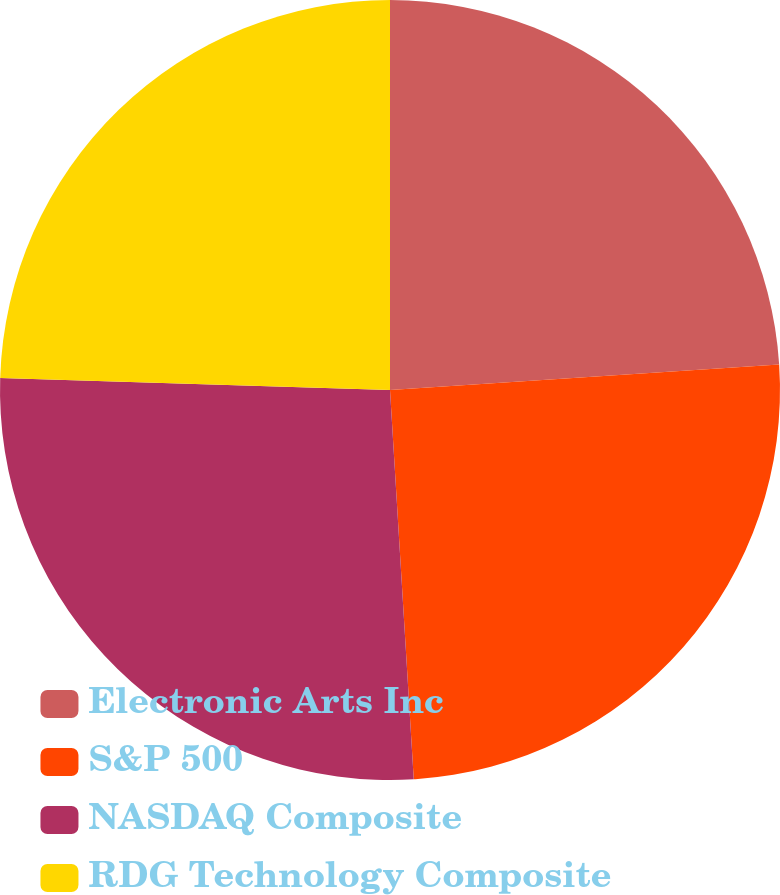Convert chart. <chart><loc_0><loc_0><loc_500><loc_500><pie_chart><fcel>Electronic Arts Inc<fcel>S&P 500<fcel>NASDAQ Composite<fcel>RDG Technology Composite<nl><fcel>23.96%<fcel>25.07%<fcel>26.46%<fcel>24.51%<nl></chart> 